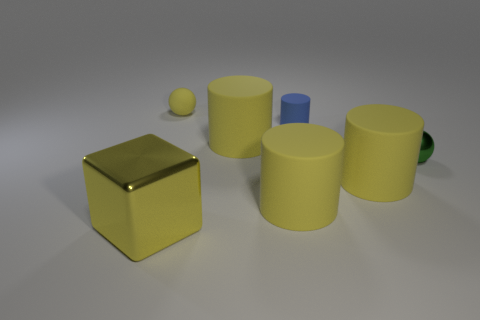Add 2 small blue cubes. How many objects exist? 9 Subtract all tiny blue cylinders. How many cylinders are left? 3 Subtract 1 yellow cubes. How many objects are left? 6 Subtract all spheres. How many objects are left? 5 Subtract 3 cylinders. How many cylinders are left? 1 Subtract all red cylinders. Subtract all brown cubes. How many cylinders are left? 4 Subtract all green cubes. How many yellow balls are left? 1 Subtract all metal spheres. Subtract all small metallic objects. How many objects are left? 5 Add 6 tiny yellow balls. How many tiny yellow balls are left? 7 Add 3 tiny green spheres. How many tiny green spheres exist? 4 